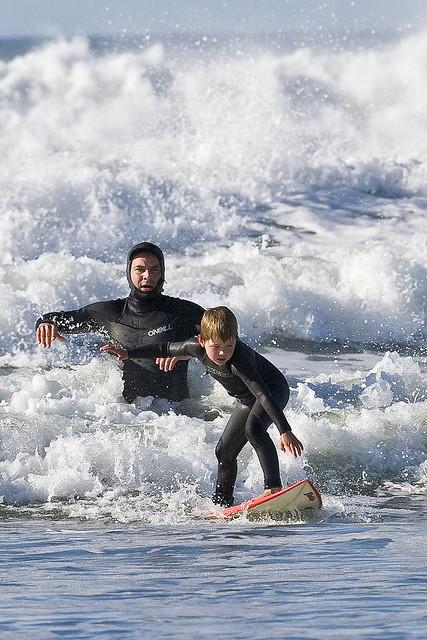Which surfer is more experienced? Please explain your reasoning. larger one. The older person has more years of experience because he's much older than the child 